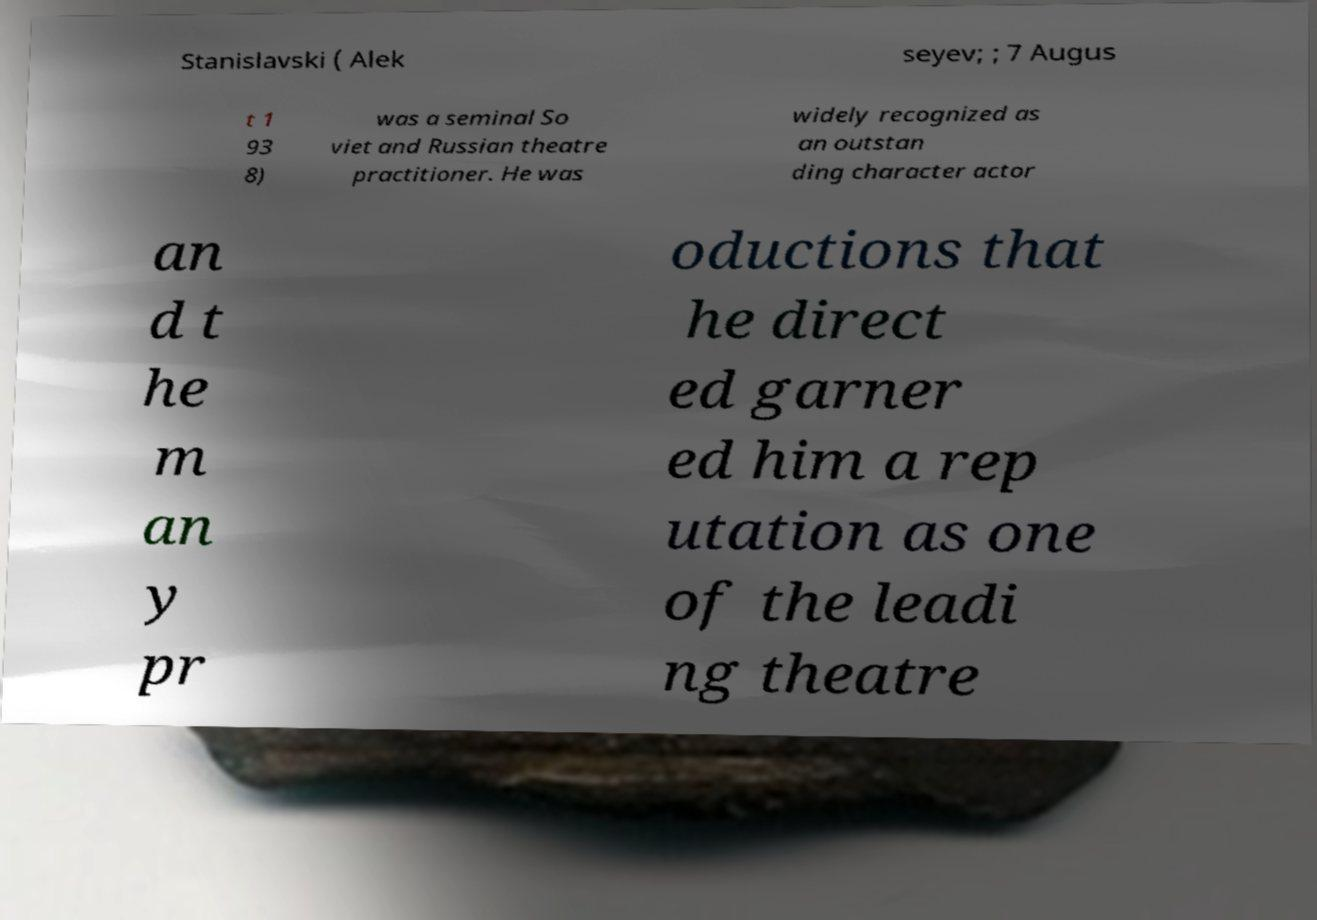There's text embedded in this image that I need extracted. Can you transcribe it verbatim? Stanislavski ( Alek seyev; ; 7 Augus t 1 93 8) was a seminal So viet and Russian theatre practitioner. He was widely recognized as an outstan ding character actor an d t he m an y pr oductions that he direct ed garner ed him a rep utation as one of the leadi ng theatre 